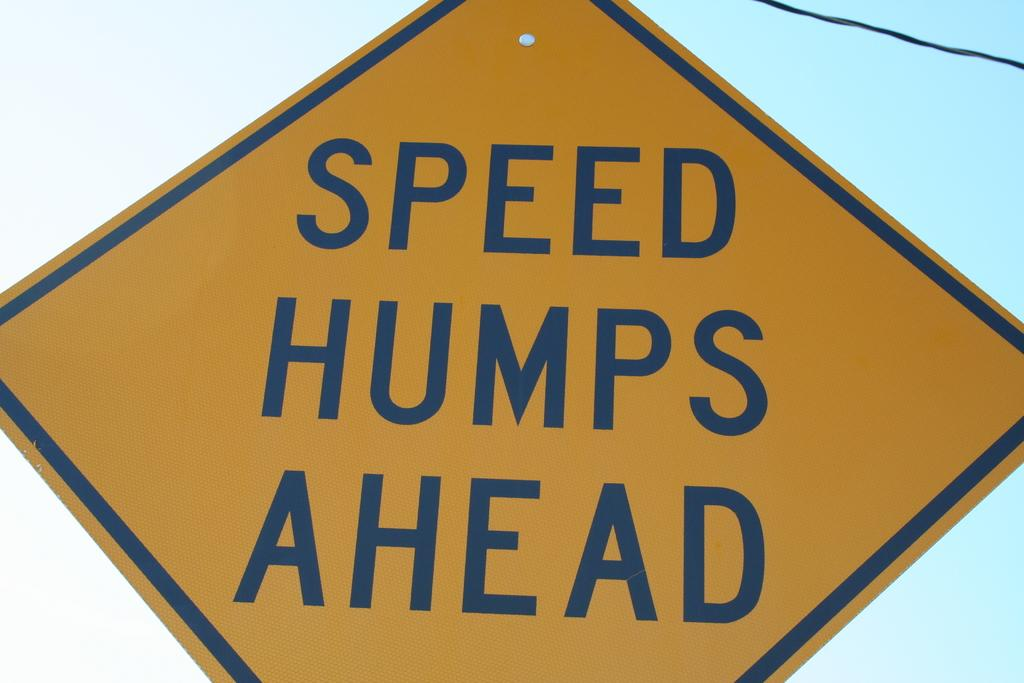<image>
Offer a succinct explanation of the picture presented. A yellow sign warns people that there are speed humps ahead. 